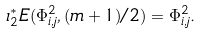<formula> <loc_0><loc_0><loc_500><loc_500>\iota _ { 2 } ^ { * } E ( \Phi _ { i , j } ^ { 2 } , ( m + 1 ) / 2 ) = \Phi _ { i , j } ^ { 2 } .</formula> 